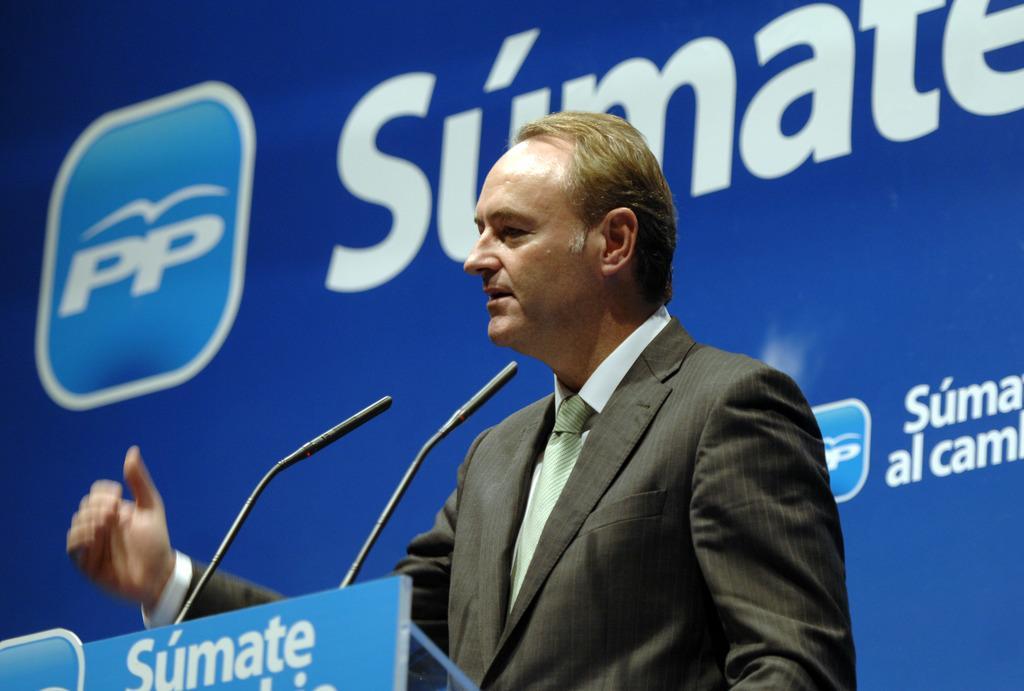Describe this image in one or two sentences. In this image we can see one person standing near to the podium and talking. There are two microphones and one name board attached to the podium. There is a blue background with some text. 